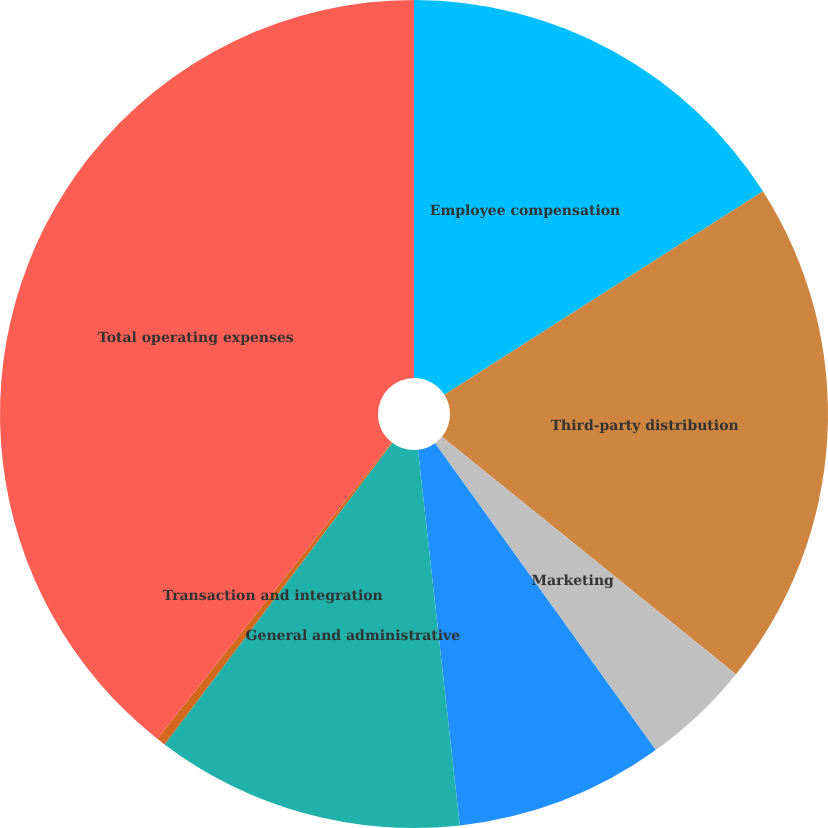Convert chart to OTSL. <chart><loc_0><loc_0><loc_500><loc_500><pie_chart><fcel>Employee compensation<fcel>Third-party distribution<fcel>Marketing<fcel>Property office and technology<fcel>General and administrative<fcel>Transaction and integration<fcel>Total operating expenses<nl><fcel>15.96%<fcel>19.86%<fcel>4.26%<fcel>8.16%<fcel>12.06%<fcel>0.35%<fcel>39.36%<nl></chart> 